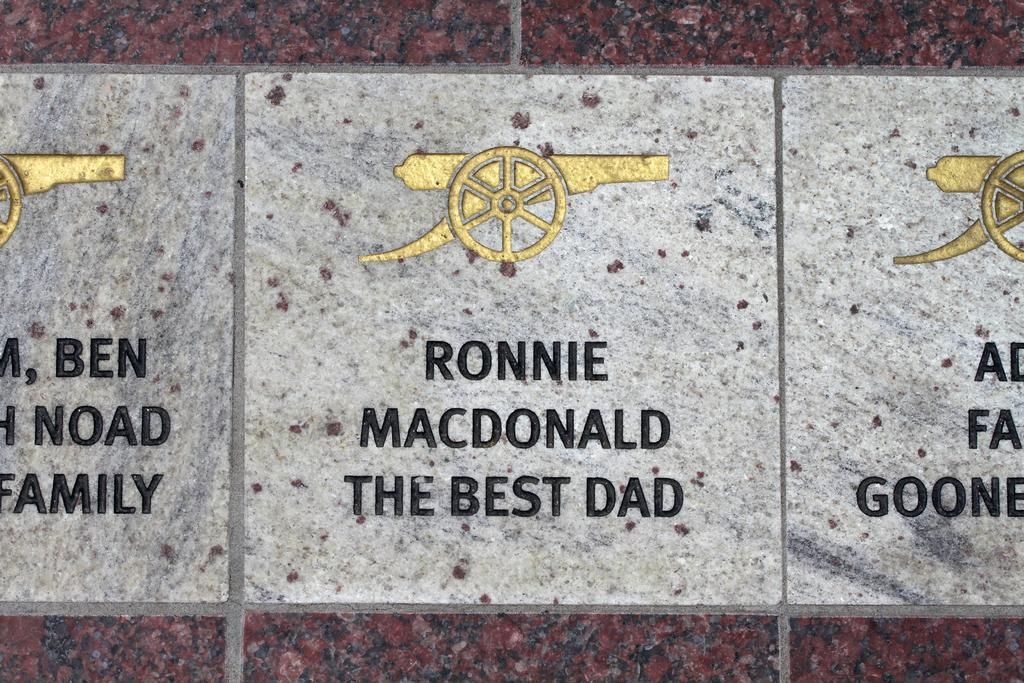What is the main object in the image? There is a historical plaque in the image. What can be found on the plaque? The plaque has symbols and text on it. How many steps can be seen leading up to the window in the image? There is no mention of steps or a window in the image; it only features a historical plaque with symbols and text. 